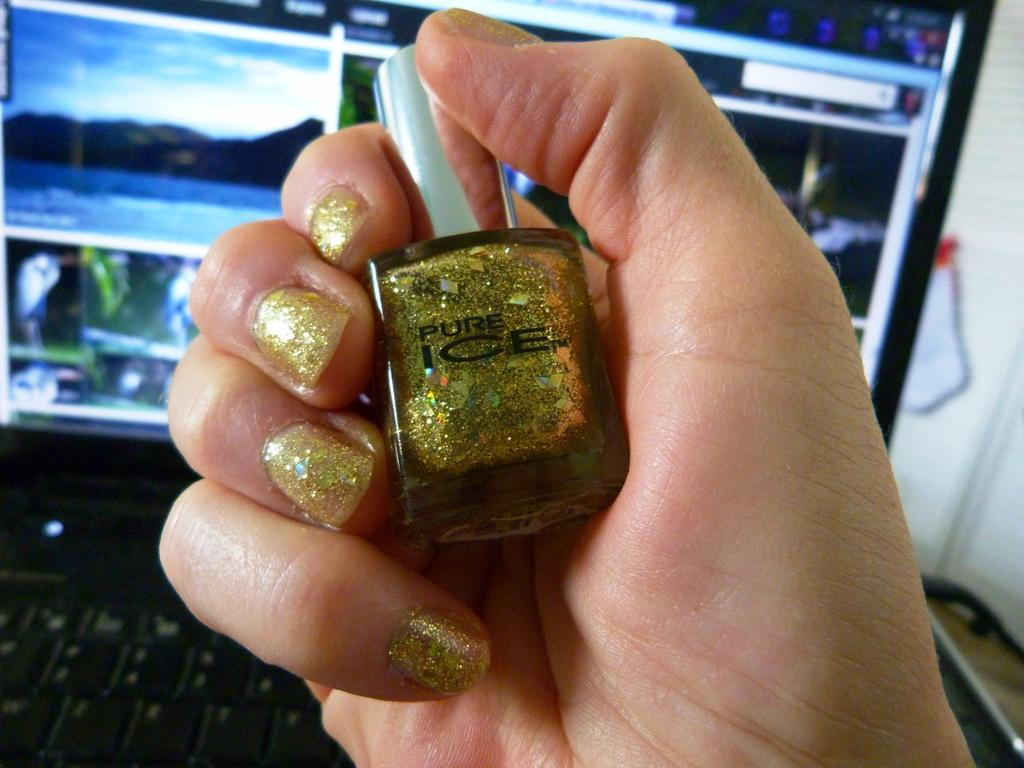<image>
Share a concise interpretation of the image provided. A person holding gold glittery nail polish that says pure ice. 